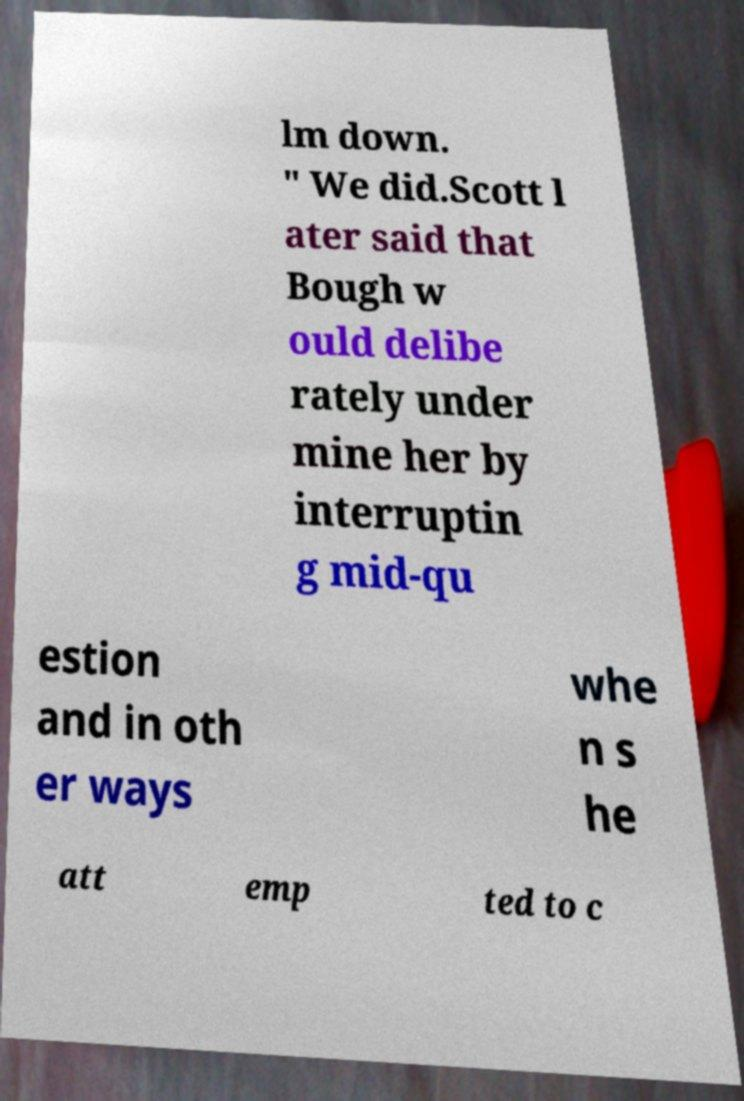Please read and relay the text visible in this image. What does it say? lm down. " We did.Scott l ater said that Bough w ould delibe rately under mine her by interruptin g mid-qu estion and in oth er ways whe n s he att emp ted to c 